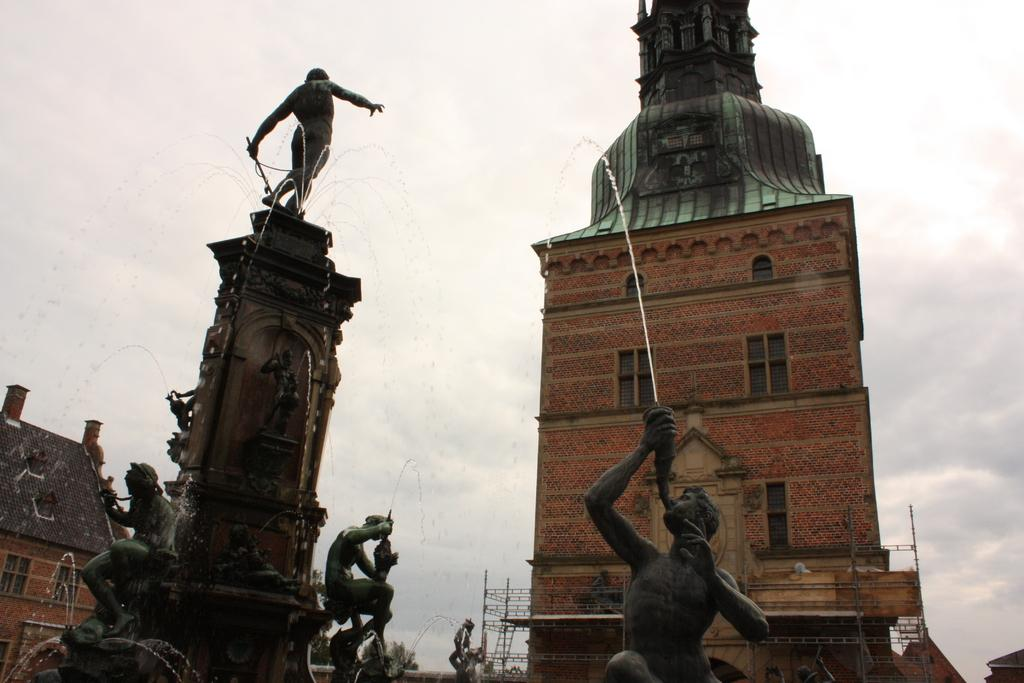What is the main feature of the image? The main feature of the image is the fountains. What can be found inside the fountains? The fountains contain statues of persons. What is the color of the statues? The statues are black in color. What can be seen in the background of the image? There are buildings, trees, and the sky visible in the background of the image. How many jars are placed on the statues in the image? There are no jars present on the statues in the image. Can you describe the pen that the person in the fountain is holding? There are no pens or persons holding pens in the image; the fountains contain statues of persons. 